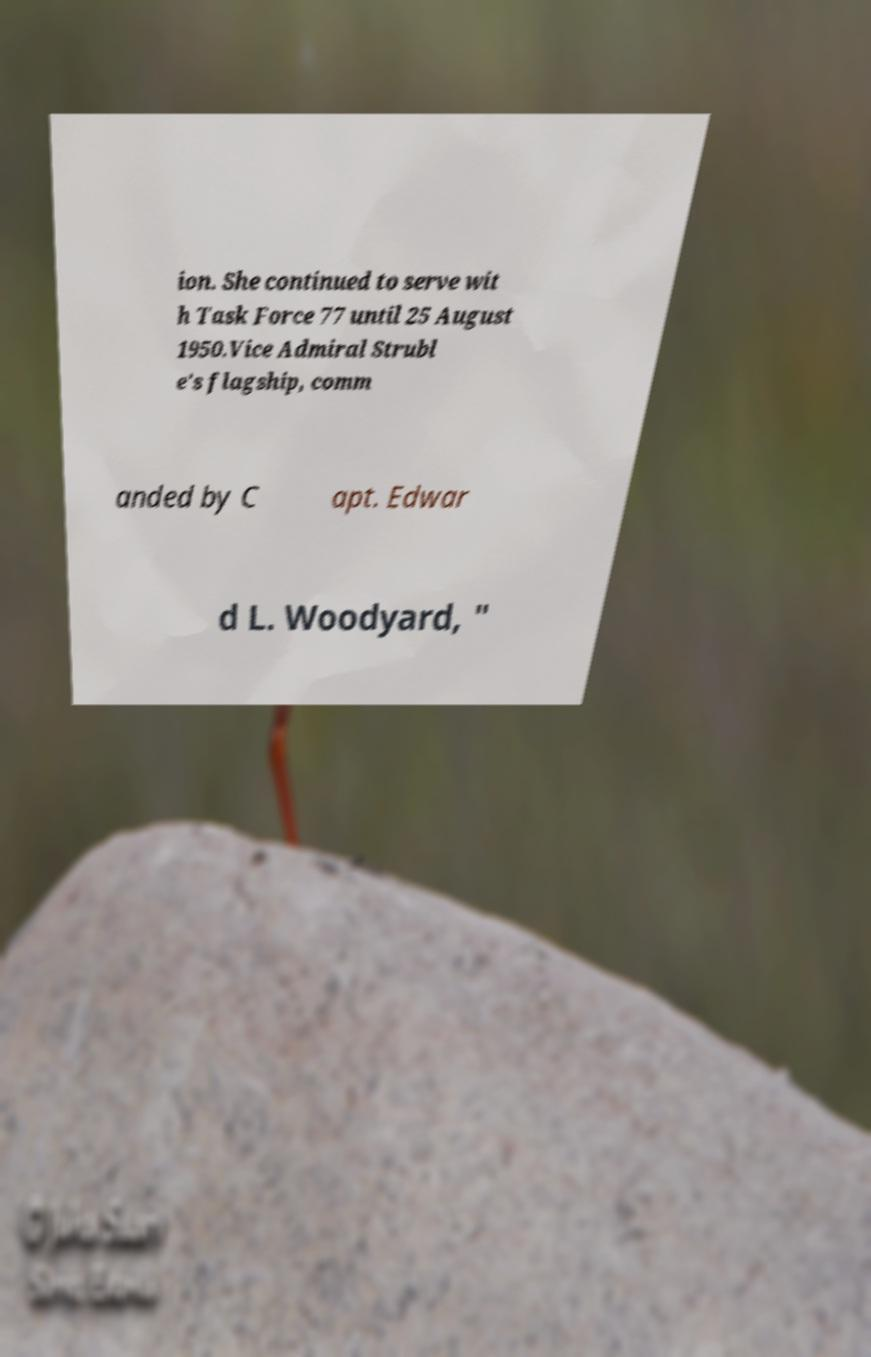For documentation purposes, I need the text within this image transcribed. Could you provide that? ion. She continued to serve wit h Task Force 77 until 25 August 1950.Vice Admiral Strubl e's flagship, comm anded by C apt. Edwar d L. Woodyard, " 